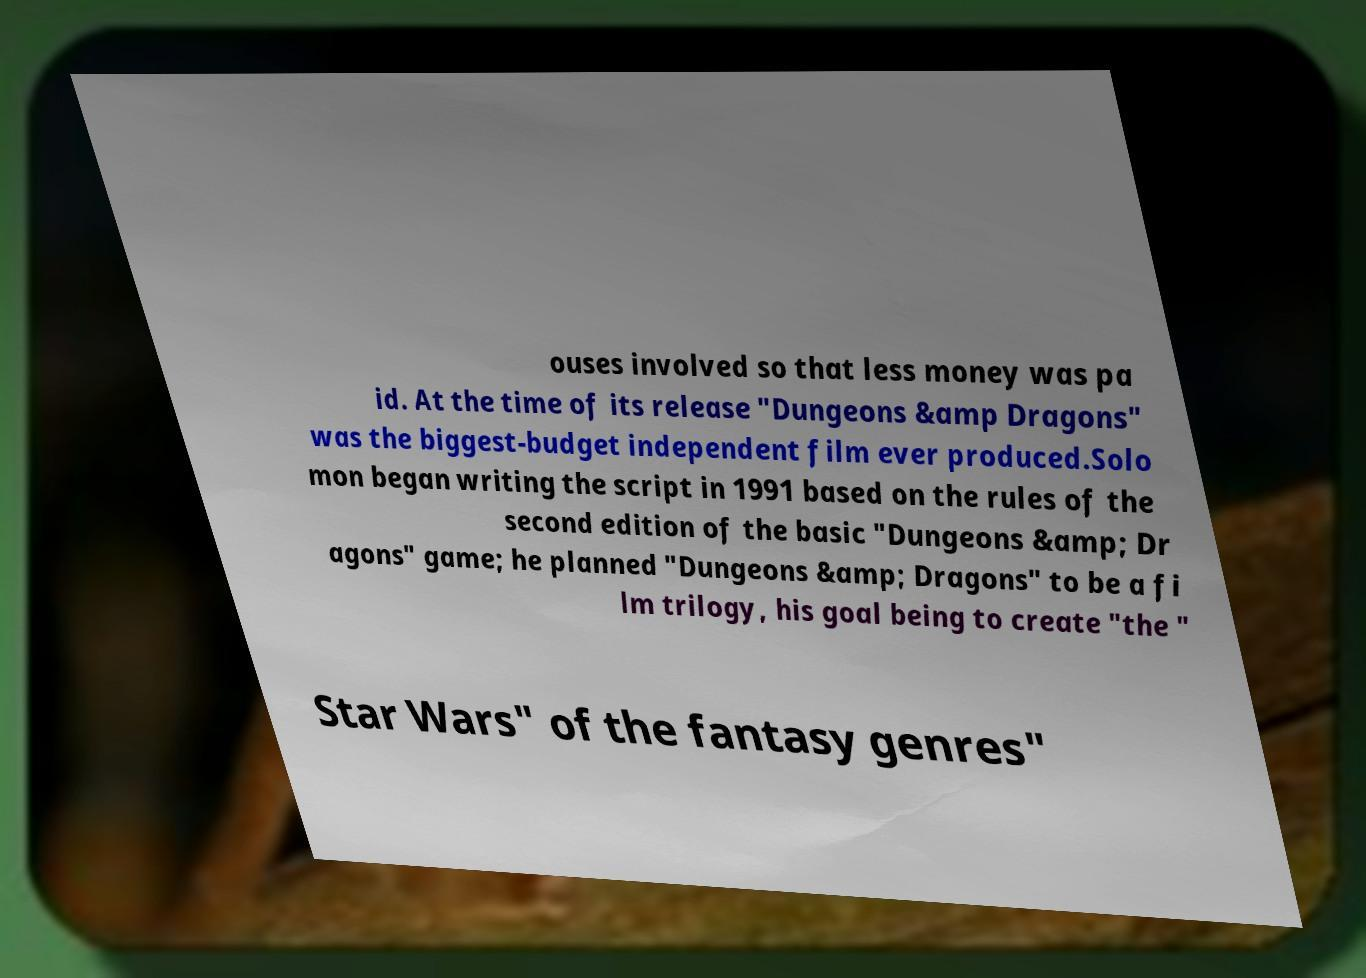Can you accurately transcribe the text from the provided image for me? ouses involved so that less money was pa id. At the time of its release "Dungeons &amp Dragons" was the biggest-budget independent film ever produced.Solo mon began writing the script in 1991 based on the rules of the second edition of the basic "Dungeons &amp; Dr agons" game; he planned "Dungeons &amp; Dragons" to be a fi lm trilogy, his goal being to create "the " Star Wars" of the fantasy genres" 